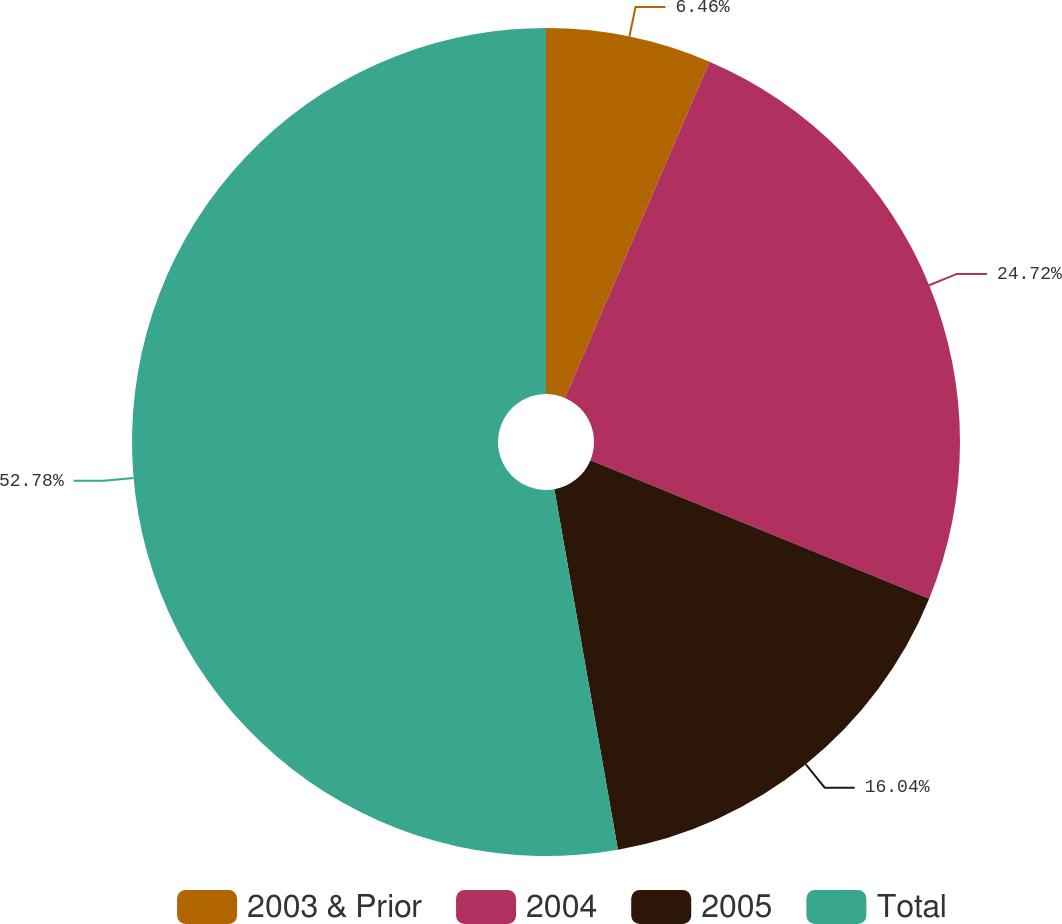Convert chart to OTSL. <chart><loc_0><loc_0><loc_500><loc_500><pie_chart><fcel>2003 & Prior<fcel>2004<fcel>2005<fcel>Total<nl><fcel>6.46%<fcel>24.72%<fcel>16.04%<fcel>52.78%<nl></chart> 